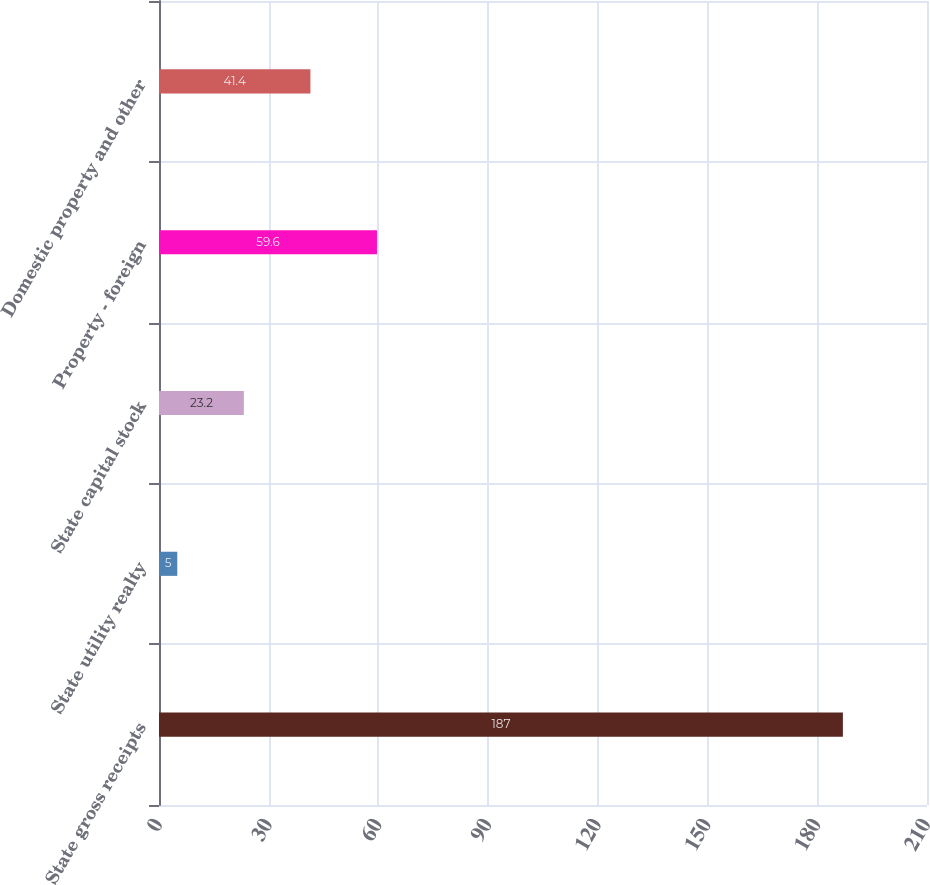<chart> <loc_0><loc_0><loc_500><loc_500><bar_chart><fcel>State gross receipts<fcel>State utility realty<fcel>State capital stock<fcel>Property - foreign<fcel>Domestic property and other<nl><fcel>187<fcel>5<fcel>23.2<fcel>59.6<fcel>41.4<nl></chart> 